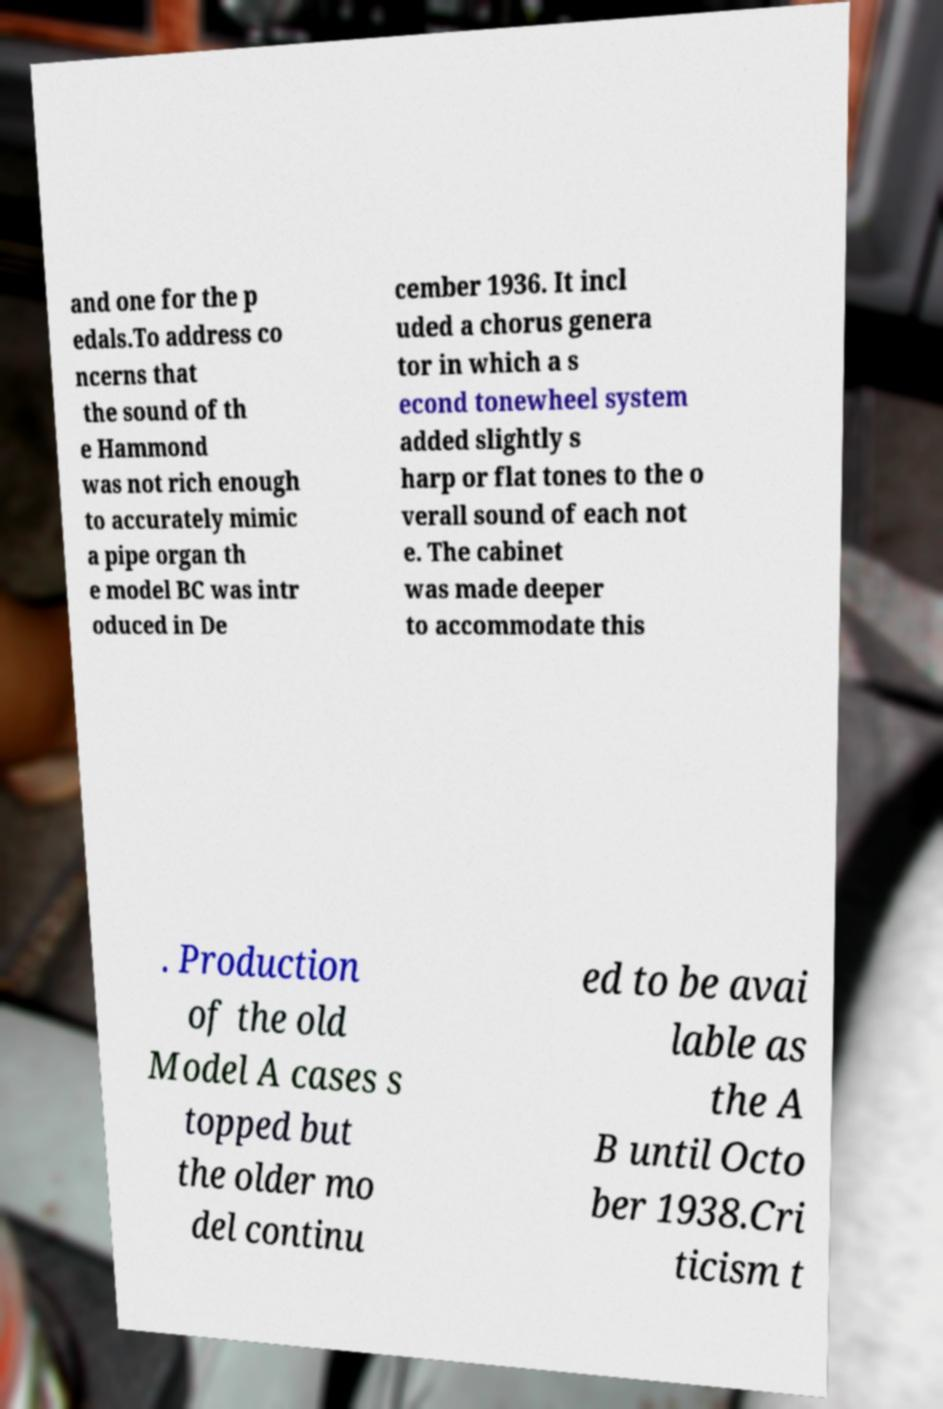Could you assist in decoding the text presented in this image and type it out clearly? and one for the p edals.To address co ncerns that the sound of th e Hammond was not rich enough to accurately mimic a pipe organ th e model BC was intr oduced in De cember 1936. It incl uded a chorus genera tor in which a s econd tonewheel system added slightly s harp or flat tones to the o verall sound of each not e. The cabinet was made deeper to accommodate this . Production of the old Model A cases s topped but the older mo del continu ed to be avai lable as the A B until Octo ber 1938.Cri ticism t 